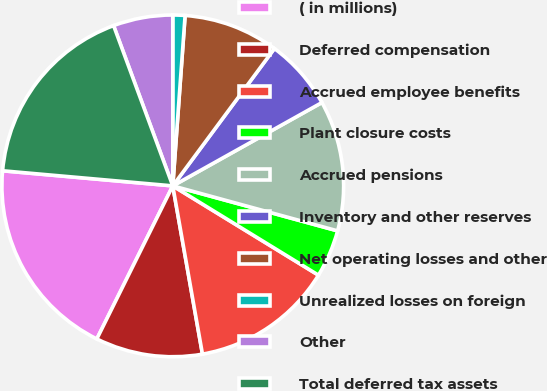Convert chart to OTSL. <chart><loc_0><loc_0><loc_500><loc_500><pie_chart><fcel>( in millions)<fcel>Deferred compensation<fcel>Accrued employee benefits<fcel>Plant closure costs<fcel>Accrued pensions<fcel>Inventory and other reserves<fcel>Net operating losses and other<fcel>Unrealized losses on foreign<fcel>Other<fcel>Total deferred tax assets<nl><fcel>19.08%<fcel>10.11%<fcel>13.47%<fcel>4.51%<fcel>12.35%<fcel>6.75%<fcel>8.99%<fcel>1.15%<fcel>5.63%<fcel>17.96%<nl></chart> 